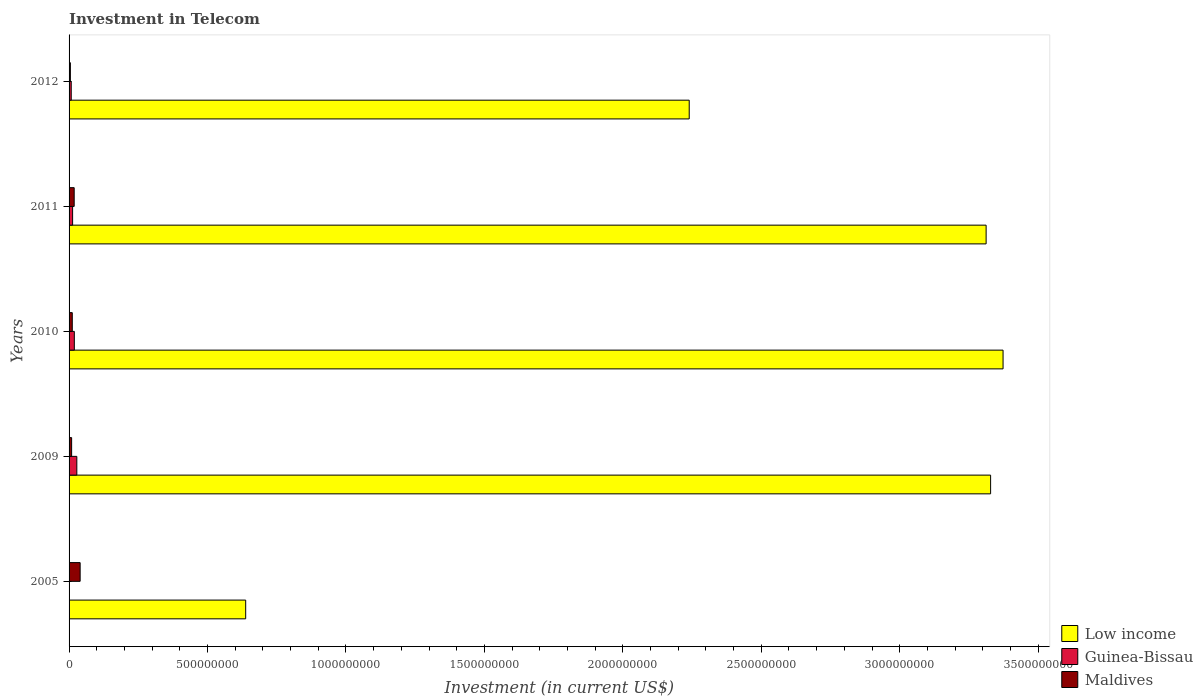How many different coloured bars are there?
Give a very brief answer. 3. How many groups of bars are there?
Your response must be concise. 5. Are the number of bars per tick equal to the number of legend labels?
Ensure brevity in your answer.  Yes. How many bars are there on the 5th tick from the top?
Make the answer very short. 3. How many bars are there on the 4th tick from the bottom?
Provide a succinct answer. 3. What is the label of the 4th group of bars from the top?
Provide a short and direct response. 2009. In how many cases, is the number of bars for a given year not equal to the number of legend labels?
Your answer should be very brief. 0. What is the amount invested in telecom in Guinea-Bissau in 2011?
Give a very brief answer. 1.28e+07. Across all years, what is the maximum amount invested in telecom in Low income?
Offer a very short reply. 3.37e+09. Across all years, what is the minimum amount invested in telecom in Maldives?
Your answer should be compact. 4.70e+06. In which year was the amount invested in telecom in Low income maximum?
Your answer should be compact. 2010. What is the total amount invested in telecom in Maldives in the graph?
Your answer should be compact. 8.40e+07. What is the difference between the amount invested in telecom in Maldives in 2005 and that in 2010?
Your response must be concise. 2.84e+07. What is the difference between the amount invested in telecom in Guinea-Bissau in 2010 and the amount invested in telecom in Maldives in 2011?
Make the answer very short. 5.00e+05. What is the average amount invested in telecom in Low income per year?
Ensure brevity in your answer.  2.58e+09. In the year 2011, what is the difference between the amount invested in telecom in Maldives and amount invested in telecom in Low income?
Your response must be concise. -3.29e+09. What is the ratio of the amount invested in telecom in Low income in 2009 to that in 2012?
Your answer should be compact. 1.49. Is the amount invested in telecom in Maldives in 2009 less than that in 2012?
Make the answer very short. No. Is the difference between the amount invested in telecom in Maldives in 2005 and 2012 greater than the difference between the amount invested in telecom in Low income in 2005 and 2012?
Your answer should be compact. Yes. What is the difference between the highest and the second highest amount invested in telecom in Maldives?
Provide a succinct answer. 2.15e+07. What is the difference between the highest and the lowest amount invested in telecom in Maldives?
Your answer should be very brief. 3.53e+07. In how many years, is the amount invested in telecom in Guinea-Bissau greater than the average amount invested in telecom in Guinea-Bissau taken over all years?
Provide a succinct answer. 2. What does the 2nd bar from the top in 2011 represents?
Give a very brief answer. Guinea-Bissau. What does the 2nd bar from the bottom in 2011 represents?
Make the answer very short. Guinea-Bissau. Is it the case that in every year, the sum of the amount invested in telecom in Low income and amount invested in telecom in Guinea-Bissau is greater than the amount invested in telecom in Maldives?
Your response must be concise. Yes. Are all the bars in the graph horizontal?
Provide a succinct answer. Yes. Are the values on the major ticks of X-axis written in scientific E-notation?
Offer a very short reply. No. Where does the legend appear in the graph?
Provide a short and direct response. Bottom right. How are the legend labels stacked?
Your response must be concise. Vertical. What is the title of the graph?
Your answer should be very brief. Investment in Telecom. What is the label or title of the X-axis?
Give a very brief answer. Investment (in current US$). What is the label or title of the Y-axis?
Make the answer very short. Years. What is the Investment (in current US$) of Low income in 2005?
Offer a terse response. 6.38e+08. What is the Investment (in current US$) in Maldives in 2005?
Give a very brief answer. 4.00e+07. What is the Investment (in current US$) of Low income in 2009?
Offer a terse response. 3.33e+09. What is the Investment (in current US$) in Guinea-Bissau in 2009?
Keep it short and to the point. 2.80e+07. What is the Investment (in current US$) of Maldives in 2009?
Keep it short and to the point. 9.20e+06. What is the Investment (in current US$) of Low income in 2010?
Offer a terse response. 3.37e+09. What is the Investment (in current US$) of Guinea-Bissau in 2010?
Make the answer very short. 1.90e+07. What is the Investment (in current US$) of Maldives in 2010?
Provide a short and direct response. 1.16e+07. What is the Investment (in current US$) of Low income in 2011?
Ensure brevity in your answer.  3.31e+09. What is the Investment (in current US$) of Guinea-Bissau in 2011?
Provide a short and direct response. 1.28e+07. What is the Investment (in current US$) of Maldives in 2011?
Provide a short and direct response. 1.85e+07. What is the Investment (in current US$) in Low income in 2012?
Offer a very short reply. 2.24e+09. What is the Investment (in current US$) of Guinea-Bissau in 2012?
Your answer should be compact. 7.80e+06. What is the Investment (in current US$) in Maldives in 2012?
Your answer should be compact. 4.70e+06. Across all years, what is the maximum Investment (in current US$) in Low income?
Make the answer very short. 3.37e+09. Across all years, what is the maximum Investment (in current US$) of Guinea-Bissau?
Offer a very short reply. 2.80e+07. Across all years, what is the maximum Investment (in current US$) of Maldives?
Offer a very short reply. 4.00e+07. Across all years, what is the minimum Investment (in current US$) in Low income?
Your answer should be compact. 6.38e+08. Across all years, what is the minimum Investment (in current US$) of Guinea-Bissau?
Give a very brief answer. 6.00e+05. Across all years, what is the minimum Investment (in current US$) of Maldives?
Keep it short and to the point. 4.70e+06. What is the total Investment (in current US$) in Low income in the graph?
Provide a short and direct response. 1.29e+1. What is the total Investment (in current US$) in Guinea-Bissau in the graph?
Your answer should be compact. 6.82e+07. What is the total Investment (in current US$) of Maldives in the graph?
Your response must be concise. 8.40e+07. What is the difference between the Investment (in current US$) in Low income in 2005 and that in 2009?
Keep it short and to the point. -2.69e+09. What is the difference between the Investment (in current US$) of Guinea-Bissau in 2005 and that in 2009?
Offer a terse response. -2.74e+07. What is the difference between the Investment (in current US$) of Maldives in 2005 and that in 2009?
Your answer should be compact. 3.08e+07. What is the difference between the Investment (in current US$) in Low income in 2005 and that in 2010?
Give a very brief answer. -2.74e+09. What is the difference between the Investment (in current US$) in Guinea-Bissau in 2005 and that in 2010?
Offer a terse response. -1.84e+07. What is the difference between the Investment (in current US$) in Maldives in 2005 and that in 2010?
Your response must be concise. 2.84e+07. What is the difference between the Investment (in current US$) in Low income in 2005 and that in 2011?
Your response must be concise. -2.67e+09. What is the difference between the Investment (in current US$) of Guinea-Bissau in 2005 and that in 2011?
Give a very brief answer. -1.22e+07. What is the difference between the Investment (in current US$) in Maldives in 2005 and that in 2011?
Keep it short and to the point. 2.15e+07. What is the difference between the Investment (in current US$) of Low income in 2005 and that in 2012?
Ensure brevity in your answer.  -1.60e+09. What is the difference between the Investment (in current US$) in Guinea-Bissau in 2005 and that in 2012?
Offer a very short reply. -7.20e+06. What is the difference between the Investment (in current US$) of Maldives in 2005 and that in 2012?
Your response must be concise. 3.53e+07. What is the difference between the Investment (in current US$) in Low income in 2009 and that in 2010?
Provide a succinct answer. -4.50e+07. What is the difference between the Investment (in current US$) of Guinea-Bissau in 2009 and that in 2010?
Your response must be concise. 9.00e+06. What is the difference between the Investment (in current US$) in Maldives in 2009 and that in 2010?
Make the answer very short. -2.40e+06. What is the difference between the Investment (in current US$) of Low income in 2009 and that in 2011?
Make the answer very short. 1.62e+07. What is the difference between the Investment (in current US$) of Guinea-Bissau in 2009 and that in 2011?
Your answer should be compact. 1.52e+07. What is the difference between the Investment (in current US$) of Maldives in 2009 and that in 2011?
Ensure brevity in your answer.  -9.30e+06. What is the difference between the Investment (in current US$) of Low income in 2009 and that in 2012?
Your answer should be compact. 1.09e+09. What is the difference between the Investment (in current US$) in Guinea-Bissau in 2009 and that in 2012?
Give a very brief answer. 2.02e+07. What is the difference between the Investment (in current US$) in Maldives in 2009 and that in 2012?
Offer a very short reply. 4.50e+06. What is the difference between the Investment (in current US$) in Low income in 2010 and that in 2011?
Your answer should be very brief. 6.12e+07. What is the difference between the Investment (in current US$) of Guinea-Bissau in 2010 and that in 2011?
Provide a short and direct response. 6.20e+06. What is the difference between the Investment (in current US$) in Maldives in 2010 and that in 2011?
Offer a terse response. -6.90e+06. What is the difference between the Investment (in current US$) in Low income in 2010 and that in 2012?
Provide a succinct answer. 1.13e+09. What is the difference between the Investment (in current US$) in Guinea-Bissau in 2010 and that in 2012?
Offer a terse response. 1.12e+07. What is the difference between the Investment (in current US$) in Maldives in 2010 and that in 2012?
Keep it short and to the point. 6.90e+06. What is the difference between the Investment (in current US$) in Low income in 2011 and that in 2012?
Give a very brief answer. 1.07e+09. What is the difference between the Investment (in current US$) of Maldives in 2011 and that in 2012?
Your answer should be very brief. 1.38e+07. What is the difference between the Investment (in current US$) of Low income in 2005 and the Investment (in current US$) of Guinea-Bissau in 2009?
Your answer should be compact. 6.10e+08. What is the difference between the Investment (in current US$) in Low income in 2005 and the Investment (in current US$) in Maldives in 2009?
Provide a succinct answer. 6.29e+08. What is the difference between the Investment (in current US$) in Guinea-Bissau in 2005 and the Investment (in current US$) in Maldives in 2009?
Offer a terse response. -8.60e+06. What is the difference between the Investment (in current US$) of Low income in 2005 and the Investment (in current US$) of Guinea-Bissau in 2010?
Ensure brevity in your answer.  6.19e+08. What is the difference between the Investment (in current US$) in Low income in 2005 and the Investment (in current US$) in Maldives in 2010?
Make the answer very short. 6.26e+08. What is the difference between the Investment (in current US$) in Guinea-Bissau in 2005 and the Investment (in current US$) in Maldives in 2010?
Offer a very short reply. -1.10e+07. What is the difference between the Investment (in current US$) in Low income in 2005 and the Investment (in current US$) in Guinea-Bissau in 2011?
Keep it short and to the point. 6.25e+08. What is the difference between the Investment (in current US$) in Low income in 2005 and the Investment (in current US$) in Maldives in 2011?
Offer a very short reply. 6.19e+08. What is the difference between the Investment (in current US$) of Guinea-Bissau in 2005 and the Investment (in current US$) of Maldives in 2011?
Provide a succinct answer. -1.79e+07. What is the difference between the Investment (in current US$) of Low income in 2005 and the Investment (in current US$) of Guinea-Bissau in 2012?
Keep it short and to the point. 6.30e+08. What is the difference between the Investment (in current US$) in Low income in 2005 and the Investment (in current US$) in Maldives in 2012?
Make the answer very short. 6.33e+08. What is the difference between the Investment (in current US$) in Guinea-Bissau in 2005 and the Investment (in current US$) in Maldives in 2012?
Offer a terse response. -4.10e+06. What is the difference between the Investment (in current US$) in Low income in 2009 and the Investment (in current US$) in Guinea-Bissau in 2010?
Provide a short and direct response. 3.31e+09. What is the difference between the Investment (in current US$) of Low income in 2009 and the Investment (in current US$) of Maldives in 2010?
Offer a very short reply. 3.32e+09. What is the difference between the Investment (in current US$) in Guinea-Bissau in 2009 and the Investment (in current US$) in Maldives in 2010?
Make the answer very short. 1.64e+07. What is the difference between the Investment (in current US$) in Low income in 2009 and the Investment (in current US$) in Guinea-Bissau in 2011?
Provide a short and direct response. 3.32e+09. What is the difference between the Investment (in current US$) of Low income in 2009 and the Investment (in current US$) of Maldives in 2011?
Ensure brevity in your answer.  3.31e+09. What is the difference between the Investment (in current US$) of Guinea-Bissau in 2009 and the Investment (in current US$) of Maldives in 2011?
Your answer should be very brief. 9.50e+06. What is the difference between the Investment (in current US$) in Low income in 2009 and the Investment (in current US$) in Guinea-Bissau in 2012?
Your response must be concise. 3.32e+09. What is the difference between the Investment (in current US$) in Low income in 2009 and the Investment (in current US$) in Maldives in 2012?
Provide a succinct answer. 3.32e+09. What is the difference between the Investment (in current US$) in Guinea-Bissau in 2009 and the Investment (in current US$) in Maldives in 2012?
Your answer should be compact. 2.33e+07. What is the difference between the Investment (in current US$) of Low income in 2010 and the Investment (in current US$) of Guinea-Bissau in 2011?
Offer a terse response. 3.36e+09. What is the difference between the Investment (in current US$) of Low income in 2010 and the Investment (in current US$) of Maldives in 2011?
Offer a very short reply. 3.35e+09. What is the difference between the Investment (in current US$) in Guinea-Bissau in 2010 and the Investment (in current US$) in Maldives in 2011?
Your answer should be very brief. 5.00e+05. What is the difference between the Investment (in current US$) in Low income in 2010 and the Investment (in current US$) in Guinea-Bissau in 2012?
Ensure brevity in your answer.  3.37e+09. What is the difference between the Investment (in current US$) in Low income in 2010 and the Investment (in current US$) in Maldives in 2012?
Offer a very short reply. 3.37e+09. What is the difference between the Investment (in current US$) of Guinea-Bissau in 2010 and the Investment (in current US$) of Maldives in 2012?
Provide a short and direct response. 1.43e+07. What is the difference between the Investment (in current US$) of Low income in 2011 and the Investment (in current US$) of Guinea-Bissau in 2012?
Keep it short and to the point. 3.30e+09. What is the difference between the Investment (in current US$) of Low income in 2011 and the Investment (in current US$) of Maldives in 2012?
Make the answer very short. 3.31e+09. What is the difference between the Investment (in current US$) of Guinea-Bissau in 2011 and the Investment (in current US$) of Maldives in 2012?
Give a very brief answer. 8.10e+06. What is the average Investment (in current US$) of Low income per year?
Your response must be concise. 2.58e+09. What is the average Investment (in current US$) of Guinea-Bissau per year?
Offer a very short reply. 1.36e+07. What is the average Investment (in current US$) in Maldives per year?
Your answer should be compact. 1.68e+07. In the year 2005, what is the difference between the Investment (in current US$) in Low income and Investment (in current US$) in Guinea-Bissau?
Your answer should be very brief. 6.37e+08. In the year 2005, what is the difference between the Investment (in current US$) of Low income and Investment (in current US$) of Maldives?
Make the answer very short. 5.98e+08. In the year 2005, what is the difference between the Investment (in current US$) of Guinea-Bissau and Investment (in current US$) of Maldives?
Provide a succinct answer. -3.94e+07. In the year 2009, what is the difference between the Investment (in current US$) in Low income and Investment (in current US$) in Guinea-Bissau?
Make the answer very short. 3.30e+09. In the year 2009, what is the difference between the Investment (in current US$) of Low income and Investment (in current US$) of Maldives?
Ensure brevity in your answer.  3.32e+09. In the year 2009, what is the difference between the Investment (in current US$) in Guinea-Bissau and Investment (in current US$) in Maldives?
Give a very brief answer. 1.88e+07. In the year 2010, what is the difference between the Investment (in current US$) in Low income and Investment (in current US$) in Guinea-Bissau?
Keep it short and to the point. 3.35e+09. In the year 2010, what is the difference between the Investment (in current US$) in Low income and Investment (in current US$) in Maldives?
Your answer should be compact. 3.36e+09. In the year 2010, what is the difference between the Investment (in current US$) of Guinea-Bissau and Investment (in current US$) of Maldives?
Your answer should be compact. 7.40e+06. In the year 2011, what is the difference between the Investment (in current US$) of Low income and Investment (in current US$) of Guinea-Bissau?
Ensure brevity in your answer.  3.30e+09. In the year 2011, what is the difference between the Investment (in current US$) of Low income and Investment (in current US$) of Maldives?
Offer a very short reply. 3.29e+09. In the year 2011, what is the difference between the Investment (in current US$) in Guinea-Bissau and Investment (in current US$) in Maldives?
Provide a succinct answer. -5.70e+06. In the year 2012, what is the difference between the Investment (in current US$) in Low income and Investment (in current US$) in Guinea-Bissau?
Offer a terse response. 2.23e+09. In the year 2012, what is the difference between the Investment (in current US$) of Low income and Investment (in current US$) of Maldives?
Give a very brief answer. 2.24e+09. In the year 2012, what is the difference between the Investment (in current US$) of Guinea-Bissau and Investment (in current US$) of Maldives?
Your answer should be compact. 3.10e+06. What is the ratio of the Investment (in current US$) of Low income in 2005 to that in 2009?
Provide a succinct answer. 0.19. What is the ratio of the Investment (in current US$) of Guinea-Bissau in 2005 to that in 2009?
Make the answer very short. 0.02. What is the ratio of the Investment (in current US$) of Maldives in 2005 to that in 2009?
Provide a short and direct response. 4.35. What is the ratio of the Investment (in current US$) of Low income in 2005 to that in 2010?
Offer a very short reply. 0.19. What is the ratio of the Investment (in current US$) of Guinea-Bissau in 2005 to that in 2010?
Give a very brief answer. 0.03. What is the ratio of the Investment (in current US$) of Maldives in 2005 to that in 2010?
Make the answer very short. 3.45. What is the ratio of the Investment (in current US$) in Low income in 2005 to that in 2011?
Provide a short and direct response. 0.19. What is the ratio of the Investment (in current US$) of Guinea-Bissau in 2005 to that in 2011?
Keep it short and to the point. 0.05. What is the ratio of the Investment (in current US$) in Maldives in 2005 to that in 2011?
Make the answer very short. 2.16. What is the ratio of the Investment (in current US$) of Low income in 2005 to that in 2012?
Make the answer very short. 0.28. What is the ratio of the Investment (in current US$) in Guinea-Bissau in 2005 to that in 2012?
Your answer should be very brief. 0.08. What is the ratio of the Investment (in current US$) in Maldives in 2005 to that in 2012?
Your answer should be very brief. 8.51. What is the ratio of the Investment (in current US$) of Low income in 2009 to that in 2010?
Ensure brevity in your answer.  0.99. What is the ratio of the Investment (in current US$) of Guinea-Bissau in 2009 to that in 2010?
Your answer should be compact. 1.47. What is the ratio of the Investment (in current US$) in Maldives in 2009 to that in 2010?
Ensure brevity in your answer.  0.79. What is the ratio of the Investment (in current US$) of Low income in 2009 to that in 2011?
Your response must be concise. 1. What is the ratio of the Investment (in current US$) of Guinea-Bissau in 2009 to that in 2011?
Offer a very short reply. 2.19. What is the ratio of the Investment (in current US$) in Maldives in 2009 to that in 2011?
Provide a succinct answer. 0.5. What is the ratio of the Investment (in current US$) of Low income in 2009 to that in 2012?
Offer a very short reply. 1.49. What is the ratio of the Investment (in current US$) of Guinea-Bissau in 2009 to that in 2012?
Give a very brief answer. 3.59. What is the ratio of the Investment (in current US$) in Maldives in 2009 to that in 2012?
Provide a short and direct response. 1.96. What is the ratio of the Investment (in current US$) in Low income in 2010 to that in 2011?
Keep it short and to the point. 1.02. What is the ratio of the Investment (in current US$) in Guinea-Bissau in 2010 to that in 2011?
Offer a terse response. 1.48. What is the ratio of the Investment (in current US$) of Maldives in 2010 to that in 2011?
Offer a terse response. 0.63. What is the ratio of the Investment (in current US$) in Low income in 2010 to that in 2012?
Give a very brief answer. 1.51. What is the ratio of the Investment (in current US$) of Guinea-Bissau in 2010 to that in 2012?
Your answer should be compact. 2.44. What is the ratio of the Investment (in current US$) of Maldives in 2010 to that in 2012?
Your answer should be compact. 2.47. What is the ratio of the Investment (in current US$) of Low income in 2011 to that in 2012?
Your response must be concise. 1.48. What is the ratio of the Investment (in current US$) in Guinea-Bissau in 2011 to that in 2012?
Your response must be concise. 1.64. What is the ratio of the Investment (in current US$) in Maldives in 2011 to that in 2012?
Provide a succinct answer. 3.94. What is the difference between the highest and the second highest Investment (in current US$) of Low income?
Make the answer very short. 4.50e+07. What is the difference between the highest and the second highest Investment (in current US$) in Guinea-Bissau?
Give a very brief answer. 9.00e+06. What is the difference between the highest and the second highest Investment (in current US$) of Maldives?
Your answer should be compact. 2.15e+07. What is the difference between the highest and the lowest Investment (in current US$) of Low income?
Your response must be concise. 2.74e+09. What is the difference between the highest and the lowest Investment (in current US$) in Guinea-Bissau?
Your answer should be very brief. 2.74e+07. What is the difference between the highest and the lowest Investment (in current US$) of Maldives?
Provide a short and direct response. 3.53e+07. 